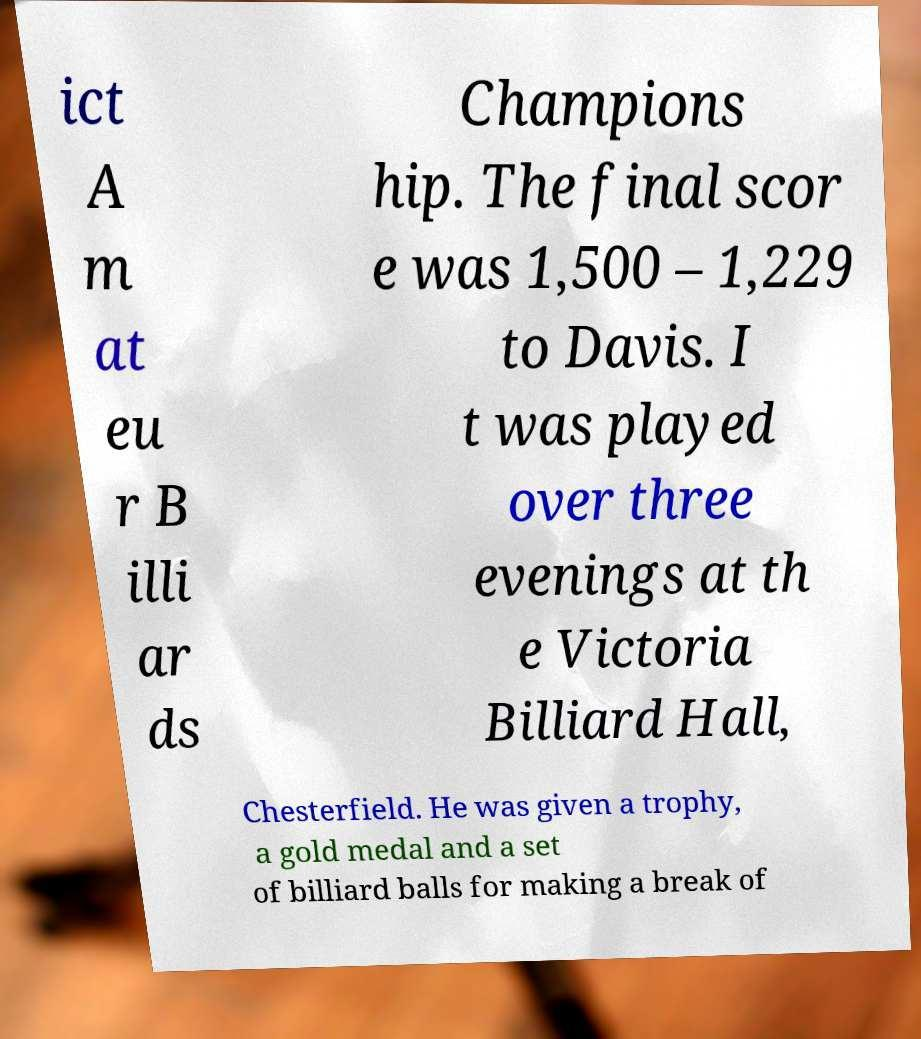Could you assist in decoding the text presented in this image and type it out clearly? ict A m at eu r B illi ar ds Champions hip. The final scor e was 1,500 – 1,229 to Davis. I t was played over three evenings at th e Victoria Billiard Hall, Chesterfield. He was given a trophy, a gold medal and a set of billiard balls for making a break of 